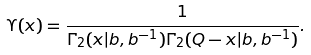Convert formula to latex. <formula><loc_0><loc_0><loc_500><loc_500>\Upsilon ( x ) = \frac { 1 } { \Gamma _ { 2 } ( x | b , b ^ { - 1 } ) \Gamma _ { 2 } ( Q - x | b , b ^ { - 1 } ) } .</formula> 